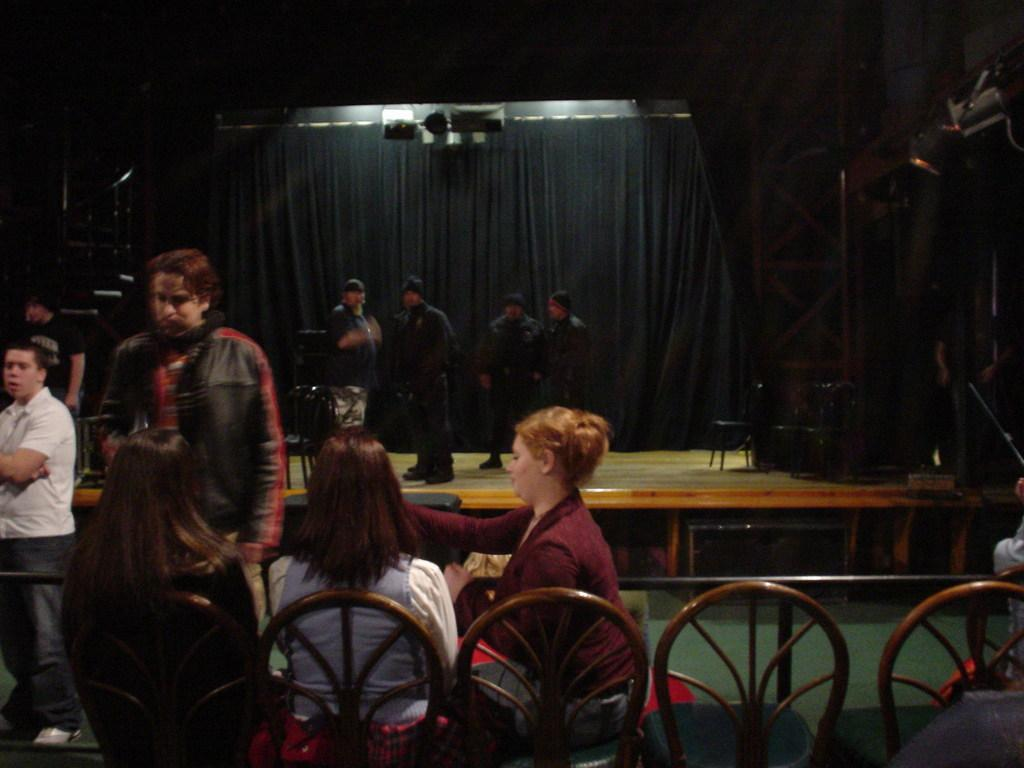What is happening in the image? There are people on stage in the image, which suggests a performance or event is taking place. What color is the background cloth in the image? The background cloth is black in color. What are the people sitting in front of the stage doing? The people sitting on chairs in front of the stage are likely watching the performance or event. What type of area is depicted in the image? The area appears to be a performance area, as indicated by the stage and seating arrangement. How many trucks are parked behind the stage in the image? There are no trucks visible in the image; it only shows people on stage and people sitting in front of the stage. What type of music is being played by the people on stage? There is no indication of music being played in the image, as it only shows people on stage and people sitting in front of the stage. 